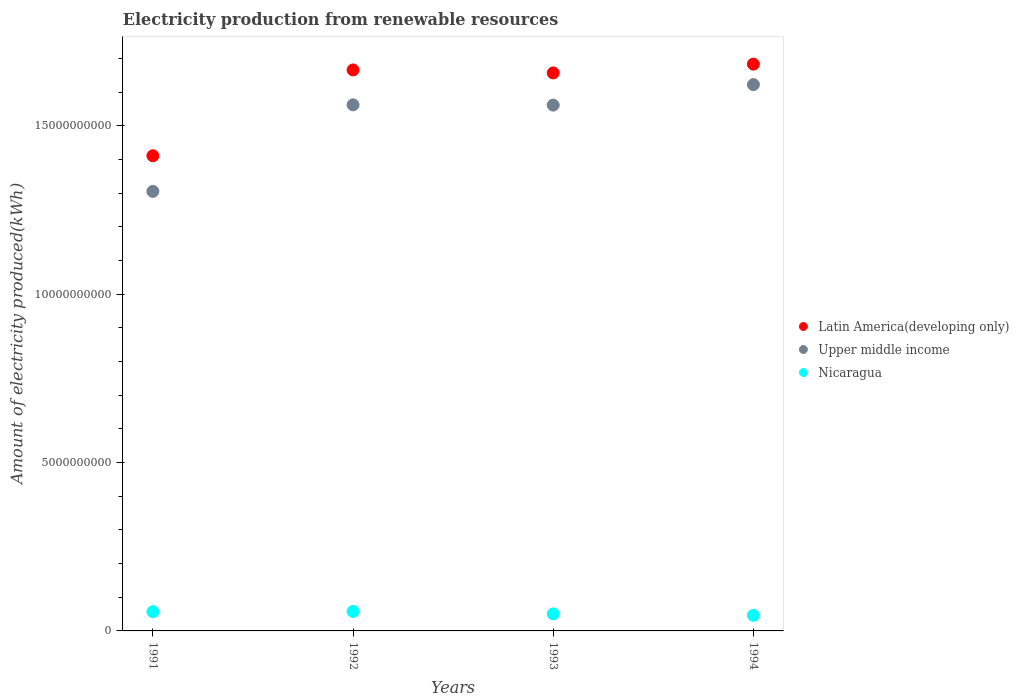What is the amount of electricity produced in Upper middle income in 1992?
Make the answer very short. 1.56e+1. Across all years, what is the maximum amount of electricity produced in Nicaragua?
Keep it short and to the point. 5.78e+08. Across all years, what is the minimum amount of electricity produced in Nicaragua?
Offer a very short reply. 4.63e+08. In which year was the amount of electricity produced in Nicaragua maximum?
Offer a very short reply. 1992. What is the total amount of electricity produced in Latin America(developing only) in the graph?
Provide a short and direct response. 6.42e+1. What is the difference between the amount of electricity produced in Nicaragua in 1991 and that in 1994?
Your response must be concise. 1.08e+08. What is the difference between the amount of electricity produced in Latin America(developing only) in 1992 and the amount of electricity produced in Upper middle income in 1994?
Make the answer very short. 4.36e+08. What is the average amount of electricity produced in Upper middle income per year?
Your answer should be compact. 1.51e+1. In the year 1992, what is the difference between the amount of electricity produced in Upper middle income and amount of electricity produced in Nicaragua?
Ensure brevity in your answer.  1.50e+1. In how many years, is the amount of electricity produced in Upper middle income greater than 2000000000 kWh?
Offer a terse response. 4. What is the ratio of the amount of electricity produced in Nicaragua in 1993 to that in 1994?
Your answer should be compact. 1.09. Is the amount of electricity produced in Upper middle income in 1991 less than that in 1993?
Your answer should be very brief. Yes. What is the difference between the highest and the second highest amount of electricity produced in Nicaragua?
Give a very brief answer. 7.00e+06. What is the difference between the highest and the lowest amount of electricity produced in Latin America(developing only)?
Offer a terse response. 2.72e+09. Is the sum of the amount of electricity produced in Latin America(developing only) in 1992 and 1994 greater than the maximum amount of electricity produced in Upper middle income across all years?
Make the answer very short. Yes. Does the amount of electricity produced in Upper middle income monotonically increase over the years?
Offer a terse response. No. How many dotlines are there?
Provide a succinct answer. 3. What is the difference between two consecutive major ticks on the Y-axis?
Make the answer very short. 5.00e+09. Are the values on the major ticks of Y-axis written in scientific E-notation?
Offer a terse response. No. Does the graph contain any zero values?
Ensure brevity in your answer.  No. Does the graph contain grids?
Provide a succinct answer. No. How many legend labels are there?
Keep it short and to the point. 3. How are the legend labels stacked?
Ensure brevity in your answer.  Vertical. What is the title of the graph?
Ensure brevity in your answer.  Electricity production from renewable resources. Does "Gambia, The" appear as one of the legend labels in the graph?
Offer a terse response. No. What is the label or title of the X-axis?
Offer a very short reply. Years. What is the label or title of the Y-axis?
Offer a terse response. Amount of electricity produced(kWh). What is the Amount of electricity produced(kWh) in Latin America(developing only) in 1991?
Provide a succinct answer. 1.41e+1. What is the Amount of electricity produced(kWh) in Upper middle income in 1991?
Make the answer very short. 1.31e+1. What is the Amount of electricity produced(kWh) of Nicaragua in 1991?
Your response must be concise. 5.71e+08. What is the Amount of electricity produced(kWh) of Latin America(developing only) in 1992?
Provide a succinct answer. 1.67e+1. What is the Amount of electricity produced(kWh) in Upper middle income in 1992?
Your response must be concise. 1.56e+1. What is the Amount of electricity produced(kWh) of Nicaragua in 1992?
Offer a terse response. 5.78e+08. What is the Amount of electricity produced(kWh) in Latin America(developing only) in 1993?
Offer a terse response. 1.66e+1. What is the Amount of electricity produced(kWh) of Upper middle income in 1993?
Your response must be concise. 1.56e+1. What is the Amount of electricity produced(kWh) in Nicaragua in 1993?
Offer a very short reply. 5.06e+08. What is the Amount of electricity produced(kWh) of Latin America(developing only) in 1994?
Ensure brevity in your answer.  1.68e+1. What is the Amount of electricity produced(kWh) of Upper middle income in 1994?
Provide a short and direct response. 1.62e+1. What is the Amount of electricity produced(kWh) of Nicaragua in 1994?
Your answer should be very brief. 4.63e+08. Across all years, what is the maximum Amount of electricity produced(kWh) of Latin America(developing only)?
Provide a succinct answer. 1.68e+1. Across all years, what is the maximum Amount of electricity produced(kWh) of Upper middle income?
Give a very brief answer. 1.62e+1. Across all years, what is the maximum Amount of electricity produced(kWh) of Nicaragua?
Keep it short and to the point. 5.78e+08. Across all years, what is the minimum Amount of electricity produced(kWh) of Latin America(developing only)?
Your response must be concise. 1.41e+1. Across all years, what is the minimum Amount of electricity produced(kWh) in Upper middle income?
Keep it short and to the point. 1.31e+1. Across all years, what is the minimum Amount of electricity produced(kWh) in Nicaragua?
Give a very brief answer. 4.63e+08. What is the total Amount of electricity produced(kWh) in Latin America(developing only) in the graph?
Provide a succinct answer. 6.42e+1. What is the total Amount of electricity produced(kWh) of Upper middle income in the graph?
Make the answer very short. 6.05e+1. What is the total Amount of electricity produced(kWh) of Nicaragua in the graph?
Your answer should be compact. 2.12e+09. What is the difference between the Amount of electricity produced(kWh) of Latin America(developing only) in 1991 and that in 1992?
Give a very brief answer. -2.55e+09. What is the difference between the Amount of electricity produced(kWh) in Upper middle income in 1991 and that in 1992?
Provide a succinct answer. -2.57e+09. What is the difference between the Amount of electricity produced(kWh) in Nicaragua in 1991 and that in 1992?
Make the answer very short. -7.00e+06. What is the difference between the Amount of electricity produced(kWh) of Latin America(developing only) in 1991 and that in 1993?
Your answer should be very brief. -2.46e+09. What is the difference between the Amount of electricity produced(kWh) of Upper middle income in 1991 and that in 1993?
Offer a very short reply. -2.56e+09. What is the difference between the Amount of electricity produced(kWh) of Nicaragua in 1991 and that in 1993?
Offer a very short reply. 6.50e+07. What is the difference between the Amount of electricity produced(kWh) in Latin America(developing only) in 1991 and that in 1994?
Your response must be concise. -2.72e+09. What is the difference between the Amount of electricity produced(kWh) of Upper middle income in 1991 and that in 1994?
Keep it short and to the point. -3.17e+09. What is the difference between the Amount of electricity produced(kWh) in Nicaragua in 1991 and that in 1994?
Offer a very short reply. 1.08e+08. What is the difference between the Amount of electricity produced(kWh) of Latin America(developing only) in 1992 and that in 1993?
Your answer should be compact. 8.90e+07. What is the difference between the Amount of electricity produced(kWh) of Upper middle income in 1992 and that in 1993?
Keep it short and to the point. 8.00e+06. What is the difference between the Amount of electricity produced(kWh) in Nicaragua in 1992 and that in 1993?
Give a very brief answer. 7.20e+07. What is the difference between the Amount of electricity produced(kWh) of Latin America(developing only) in 1992 and that in 1994?
Offer a terse response. -1.72e+08. What is the difference between the Amount of electricity produced(kWh) of Upper middle income in 1992 and that in 1994?
Your response must be concise. -6.01e+08. What is the difference between the Amount of electricity produced(kWh) of Nicaragua in 1992 and that in 1994?
Your response must be concise. 1.15e+08. What is the difference between the Amount of electricity produced(kWh) in Latin America(developing only) in 1993 and that in 1994?
Give a very brief answer. -2.61e+08. What is the difference between the Amount of electricity produced(kWh) of Upper middle income in 1993 and that in 1994?
Provide a succinct answer. -6.09e+08. What is the difference between the Amount of electricity produced(kWh) in Nicaragua in 1993 and that in 1994?
Make the answer very short. 4.30e+07. What is the difference between the Amount of electricity produced(kWh) in Latin America(developing only) in 1991 and the Amount of electricity produced(kWh) in Upper middle income in 1992?
Make the answer very short. -1.51e+09. What is the difference between the Amount of electricity produced(kWh) in Latin America(developing only) in 1991 and the Amount of electricity produced(kWh) in Nicaragua in 1992?
Provide a short and direct response. 1.35e+1. What is the difference between the Amount of electricity produced(kWh) in Upper middle income in 1991 and the Amount of electricity produced(kWh) in Nicaragua in 1992?
Give a very brief answer. 1.25e+1. What is the difference between the Amount of electricity produced(kWh) of Latin America(developing only) in 1991 and the Amount of electricity produced(kWh) of Upper middle income in 1993?
Your response must be concise. -1.50e+09. What is the difference between the Amount of electricity produced(kWh) in Latin America(developing only) in 1991 and the Amount of electricity produced(kWh) in Nicaragua in 1993?
Offer a terse response. 1.36e+1. What is the difference between the Amount of electricity produced(kWh) of Upper middle income in 1991 and the Amount of electricity produced(kWh) of Nicaragua in 1993?
Offer a very short reply. 1.26e+1. What is the difference between the Amount of electricity produced(kWh) in Latin America(developing only) in 1991 and the Amount of electricity produced(kWh) in Upper middle income in 1994?
Offer a very short reply. -2.11e+09. What is the difference between the Amount of electricity produced(kWh) of Latin America(developing only) in 1991 and the Amount of electricity produced(kWh) of Nicaragua in 1994?
Keep it short and to the point. 1.37e+1. What is the difference between the Amount of electricity produced(kWh) of Upper middle income in 1991 and the Amount of electricity produced(kWh) of Nicaragua in 1994?
Provide a short and direct response. 1.26e+1. What is the difference between the Amount of electricity produced(kWh) of Latin America(developing only) in 1992 and the Amount of electricity produced(kWh) of Upper middle income in 1993?
Your answer should be very brief. 1.04e+09. What is the difference between the Amount of electricity produced(kWh) in Latin America(developing only) in 1992 and the Amount of electricity produced(kWh) in Nicaragua in 1993?
Provide a succinct answer. 1.62e+1. What is the difference between the Amount of electricity produced(kWh) in Upper middle income in 1992 and the Amount of electricity produced(kWh) in Nicaragua in 1993?
Your response must be concise. 1.51e+1. What is the difference between the Amount of electricity produced(kWh) of Latin America(developing only) in 1992 and the Amount of electricity produced(kWh) of Upper middle income in 1994?
Ensure brevity in your answer.  4.36e+08. What is the difference between the Amount of electricity produced(kWh) in Latin America(developing only) in 1992 and the Amount of electricity produced(kWh) in Nicaragua in 1994?
Your answer should be very brief. 1.62e+1. What is the difference between the Amount of electricity produced(kWh) in Upper middle income in 1992 and the Amount of electricity produced(kWh) in Nicaragua in 1994?
Keep it short and to the point. 1.52e+1. What is the difference between the Amount of electricity produced(kWh) in Latin America(developing only) in 1993 and the Amount of electricity produced(kWh) in Upper middle income in 1994?
Provide a succinct answer. 3.47e+08. What is the difference between the Amount of electricity produced(kWh) of Latin America(developing only) in 1993 and the Amount of electricity produced(kWh) of Nicaragua in 1994?
Keep it short and to the point. 1.61e+1. What is the difference between the Amount of electricity produced(kWh) of Upper middle income in 1993 and the Amount of electricity produced(kWh) of Nicaragua in 1994?
Provide a succinct answer. 1.52e+1. What is the average Amount of electricity produced(kWh) in Latin America(developing only) per year?
Make the answer very short. 1.60e+1. What is the average Amount of electricity produced(kWh) in Upper middle income per year?
Provide a short and direct response. 1.51e+1. What is the average Amount of electricity produced(kWh) in Nicaragua per year?
Keep it short and to the point. 5.30e+08. In the year 1991, what is the difference between the Amount of electricity produced(kWh) of Latin America(developing only) and Amount of electricity produced(kWh) of Upper middle income?
Your response must be concise. 1.06e+09. In the year 1991, what is the difference between the Amount of electricity produced(kWh) of Latin America(developing only) and Amount of electricity produced(kWh) of Nicaragua?
Provide a short and direct response. 1.35e+1. In the year 1991, what is the difference between the Amount of electricity produced(kWh) in Upper middle income and Amount of electricity produced(kWh) in Nicaragua?
Give a very brief answer. 1.25e+1. In the year 1992, what is the difference between the Amount of electricity produced(kWh) in Latin America(developing only) and Amount of electricity produced(kWh) in Upper middle income?
Provide a short and direct response. 1.04e+09. In the year 1992, what is the difference between the Amount of electricity produced(kWh) in Latin America(developing only) and Amount of electricity produced(kWh) in Nicaragua?
Your response must be concise. 1.61e+1. In the year 1992, what is the difference between the Amount of electricity produced(kWh) in Upper middle income and Amount of electricity produced(kWh) in Nicaragua?
Offer a terse response. 1.50e+1. In the year 1993, what is the difference between the Amount of electricity produced(kWh) in Latin America(developing only) and Amount of electricity produced(kWh) in Upper middle income?
Your answer should be compact. 9.56e+08. In the year 1993, what is the difference between the Amount of electricity produced(kWh) of Latin America(developing only) and Amount of electricity produced(kWh) of Nicaragua?
Provide a short and direct response. 1.61e+1. In the year 1993, what is the difference between the Amount of electricity produced(kWh) of Upper middle income and Amount of electricity produced(kWh) of Nicaragua?
Offer a terse response. 1.51e+1. In the year 1994, what is the difference between the Amount of electricity produced(kWh) in Latin America(developing only) and Amount of electricity produced(kWh) in Upper middle income?
Offer a very short reply. 6.08e+08. In the year 1994, what is the difference between the Amount of electricity produced(kWh) in Latin America(developing only) and Amount of electricity produced(kWh) in Nicaragua?
Your answer should be very brief. 1.64e+1. In the year 1994, what is the difference between the Amount of electricity produced(kWh) in Upper middle income and Amount of electricity produced(kWh) in Nicaragua?
Give a very brief answer. 1.58e+1. What is the ratio of the Amount of electricity produced(kWh) in Latin America(developing only) in 1991 to that in 1992?
Keep it short and to the point. 0.85. What is the ratio of the Amount of electricity produced(kWh) in Upper middle income in 1991 to that in 1992?
Offer a very short reply. 0.84. What is the ratio of the Amount of electricity produced(kWh) of Nicaragua in 1991 to that in 1992?
Provide a succinct answer. 0.99. What is the ratio of the Amount of electricity produced(kWh) in Latin America(developing only) in 1991 to that in 1993?
Provide a succinct answer. 0.85. What is the ratio of the Amount of electricity produced(kWh) in Upper middle income in 1991 to that in 1993?
Give a very brief answer. 0.84. What is the ratio of the Amount of electricity produced(kWh) of Nicaragua in 1991 to that in 1993?
Give a very brief answer. 1.13. What is the ratio of the Amount of electricity produced(kWh) of Latin America(developing only) in 1991 to that in 1994?
Give a very brief answer. 0.84. What is the ratio of the Amount of electricity produced(kWh) in Upper middle income in 1991 to that in 1994?
Give a very brief answer. 0.8. What is the ratio of the Amount of electricity produced(kWh) of Nicaragua in 1991 to that in 1994?
Provide a succinct answer. 1.23. What is the ratio of the Amount of electricity produced(kWh) in Latin America(developing only) in 1992 to that in 1993?
Provide a short and direct response. 1.01. What is the ratio of the Amount of electricity produced(kWh) in Nicaragua in 1992 to that in 1993?
Provide a succinct answer. 1.14. What is the ratio of the Amount of electricity produced(kWh) of Latin America(developing only) in 1992 to that in 1994?
Ensure brevity in your answer.  0.99. What is the ratio of the Amount of electricity produced(kWh) of Upper middle income in 1992 to that in 1994?
Keep it short and to the point. 0.96. What is the ratio of the Amount of electricity produced(kWh) in Nicaragua in 1992 to that in 1994?
Offer a terse response. 1.25. What is the ratio of the Amount of electricity produced(kWh) of Latin America(developing only) in 1993 to that in 1994?
Your answer should be compact. 0.98. What is the ratio of the Amount of electricity produced(kWh) of Upper middle income in 1993 to that in 1994?
Offer a very short reply. 0.96. What is the ratio of the Amount of electricity produced(kWh) of Nicaragua in 1993 to that in 1994?
Your answer should be very brief. 1.09. What is the difference between the highest and the second highest Amount of electricity produced(kWh) of Latin America(developing only)?
Keep it short and to the point. 1.72e+08. What is the difference between the highest and the second highest Amount of electricity produced(kWh) of Upper middle income?
Give a very brief answer. 6.01e+08. What is the difference between the highest and the second highest Amount of electricity produced(kWh) in Nicaragua?
Offer a very short reply. 7.00e+06. What is the difference between the highest and the lowest Amount of electricity produced(kWh) of Latin America(developing only)?
Provide a succinct answer. 2.72e+09. What is the difference between the highest and the lowest Amount of electricity produced(kWh) in Upper middle income?
Give a very brief answer. 3.17e+09. What is the difference between the highest and the lowest Amount of electricity produced(kWh) in Nicaragua?
Provide a short and direct response. 1.15e+08. 